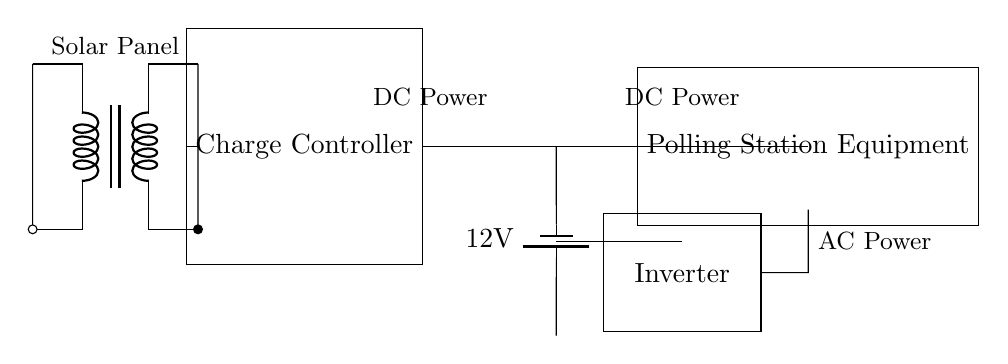What component converts solar energy into electrical energy? The solar panel is the component designed to convert solar energy into electrical energy. It is depicted on the left side of the circuit diagram.
Answer: Solar Panel What type of battery is used in this system? The circuit diagram specifies a 12V battery as the energy storage solution for the system. This detail is marked next to the battery symbol.
Answer: 12V Battery What device is used to manage the power from the solar panel? The charge controller is utilized to manage and regulate the power coming from the solar panel before it reaches the battery. It is illustrated as a rectangle connected to the solar panel and the battery.
Answer: Charge Controller What is the purpose of the inverter in this circuit? The inverter is there to convert the direct current (DC) from the battery to alternating current (AC) for the polling station equipment, as indicated by its position and connections in the diagram.
Answer: Convert DC to AC How does the electricity flow in this system? The flow of electricity starts from the solar panel to the charge controller, which then charges the battery. The inverter then takes energy from the battery to supply AC power to the polling equipment. This sequence of components and their connections shows the path of current flow through the system.
Answer: Solar Panel → Charge Controller → Battery → Inverter → Equipment What voltage does the battery supply to the load? The battery supplies a voltage of 12V to the load, as indicated next to the battery symbol in the circuit diagram, which clearly specifies the voltage amount.
Answer: 12V 